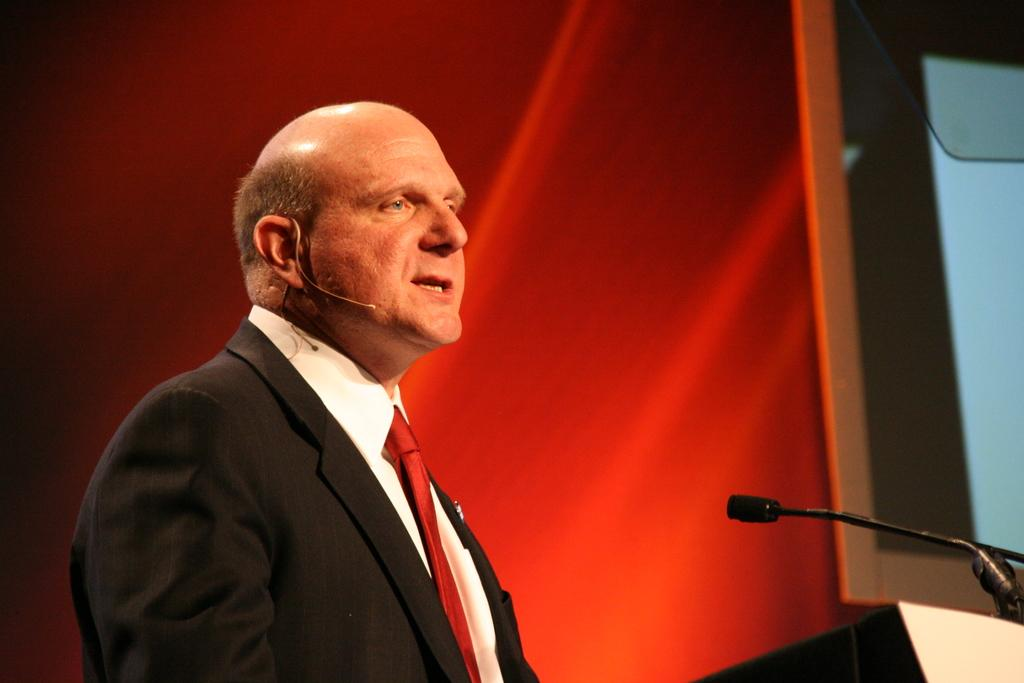Who or what is present in the image? There is a person in the image. What can be found in the bottom right corner of the image? There is an object in the bottom right corner of the image. What is the person holding in the image? A microphone is visible in the image. What is behind the person in the image? There is a background in the image. What is on the right side of the image? There is a screen on the right side of the image. How does the person's wealth contribute to the alley in the image? There is no alley present in the image, and the person's wealth is not mentioned or depicted. 